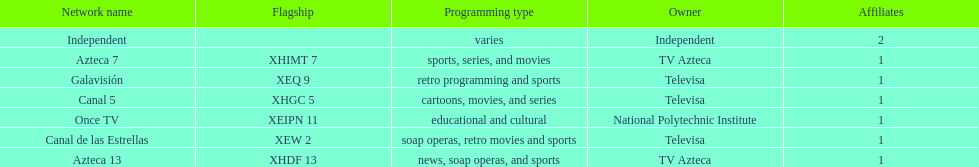What is the difference between the number of affiliates galavision has and the number of affiliates azteca 13 has? 0. 